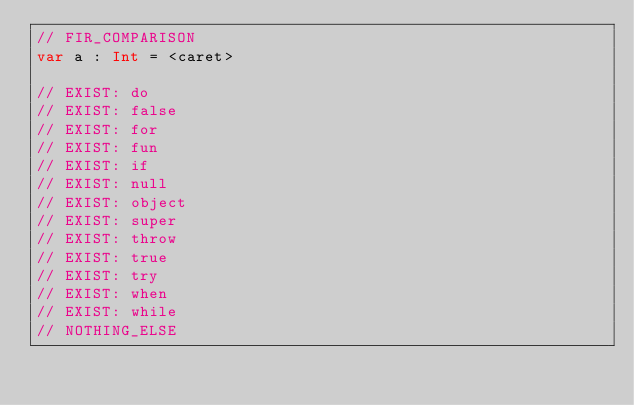Convert code to text. <code><loc_0><loc_0><loc_500><loc_500><_Kotlin_>// FIR_COMPARISON
var a : Int = <caret>

// EXIST: do
// EXIST: false
// EXIST: for
// EXIST: fun
// EXIST: if
// EXIST: null
// EXIST: object
// EXIST: super
// EXIST: throw
// EXIST: true
// EXIST: try
// EXIST: when
// EXIST: while
// NOTHING_ELSE
</code> 